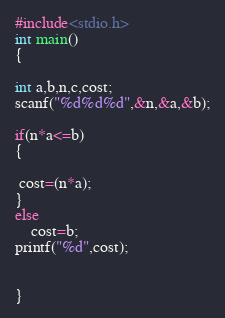<code> <loc_0><loc_0><loc_500><loc_500><_C_>#include<stdio.h>
int main()
{

int a,b,n,c,cost;
scanf("%d%d%d",&n,&a,&b);

if(n*a<=b)
{

 cost=(n*a);
}
else
    cost=b;
printf("%d",cost);


}
</code> 